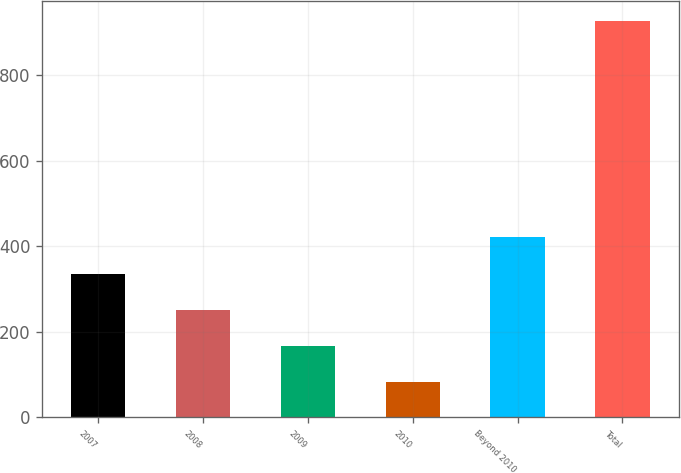<chart> <loc_0><loc_0><loc_500><loc_500><bar_chart><fcel>2007<fcel>2008<fcel>2009<fcel>2010<fcel>Beyond 2010<fcel>Total<nl><fcel>336.2<fcel>251.8<fcel>167.4<fcel>83<fcel>420.6<fcel>927<nl></chart> 